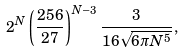<formula> <loc_0><loc_0><loc_500><loc_500>2 ^ { N } \left ( \frac { 2 5 6 } { 2 7 } \right ) ^ { N - 3 } \frac { 3 } { 1 6 \sqrt { 6 \pi N ^ { 5 } } } ,</formula> 